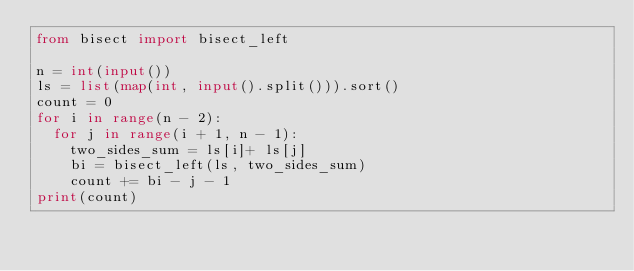Convert code to text. <code><loc_0><loc_0><loc_500><loc_500><_Python_>from bisect import bisect_left

n = int(input())
ls = list(map(int, input().split())).sort()
count = 0
for i in range(n - 2):
  for j in range(i + 1, n - 1):
    two_sides_sum = ls[i]+ ls[j]
    bi = bisect_left(ls, two_sides_sum)
    count += bi - j - 1
print(count)</code> 